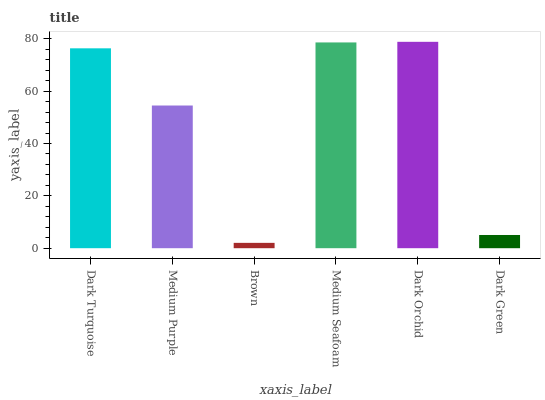Is Brown the minimum?
Answer yes or no. Yes. Is Dark Orchid the maximum?
Answer yes or no. Yes. Is Medium Purple the minimum?
Answer yes or no. No. Is Medium Purple the maximum?
Answer yes or no. No. Is Dark Turquoise greater than Medium Purple?
Answer yes or no. Yes. Is Medium Purple less than Dark Turquoise?
Answer yes or no. Yes. Is Medium Purple greater than Dark Turquoise?
Answer yes or no. No. Is Dark Turquoise less than Medium Purple?
Answer yes or no. No. Is Dark Turquoise the high median?
Answer yes or no. Yes. Is Medium Purple the low median?
Answer yes or no. Yes. Is Medium Seafoam the high median?
Answer yes or no. No. Is Brown the low median?
Answer yes or no. No. 